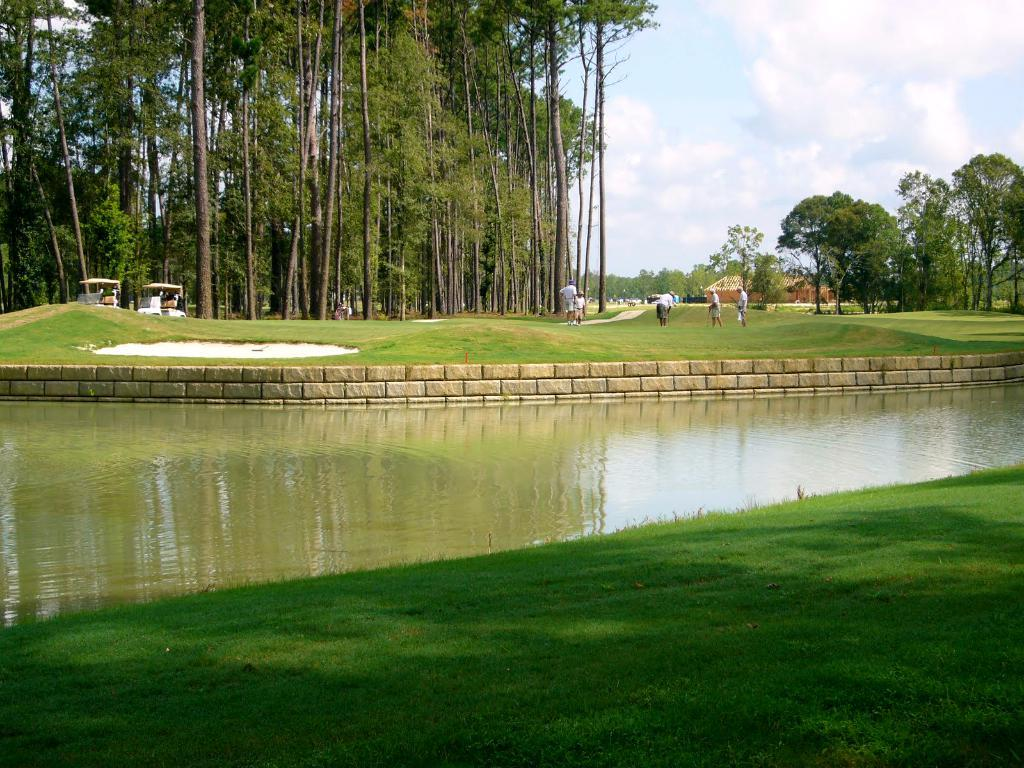What type of natural environment is depicted in the image? The image contains grass, water, trees, and a house in the background, suggesting a natural setting. Can you describe the water in the image? The water is visible in the image, but its specific characteristics are not mentioned in the facts. What is the man-made structure present in the image? There is a wall in the image. What can be seen in the background of the image? In the background, there are people visible, as well as trees, a house, and the sky. What is the condition of the sky in the image? The sky is visible in the background, and clouds are present. What is the texture of the home in the image? There is no home present in the image; it features a wall and a house in the background, but neither is described as a "home." 